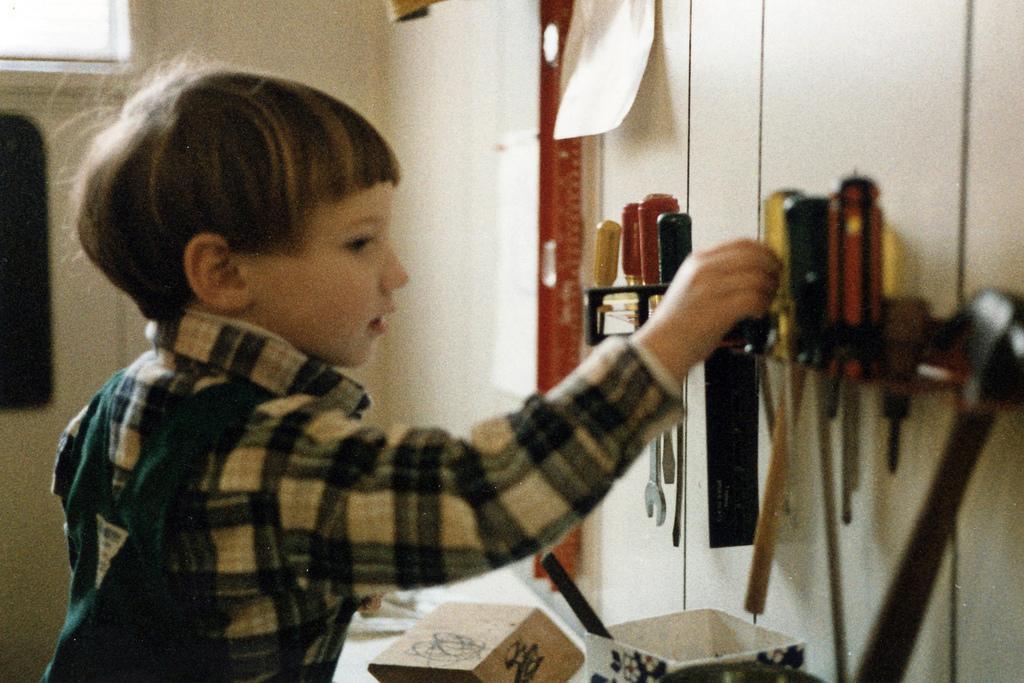In one or two sentences, can you explain what this image depicts? In this picture we can see a boy. There are few tools in the rack. We can see a paper on the wall. There is a box and a bowl. 